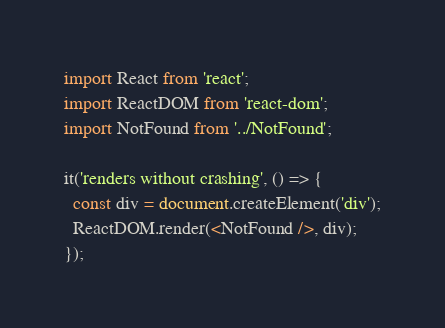<code> <loc_0><loc_0><loc_500><loc_500><_JavaScript_>import React from 'react';
import ReactDOM from 'react-dom';
import NotFound from '../NotFound';

it('renders without crashing', () => {
  const div = document.createElement('div');
  ReactDOM.render(<NotFound />, div);
});
</code> 